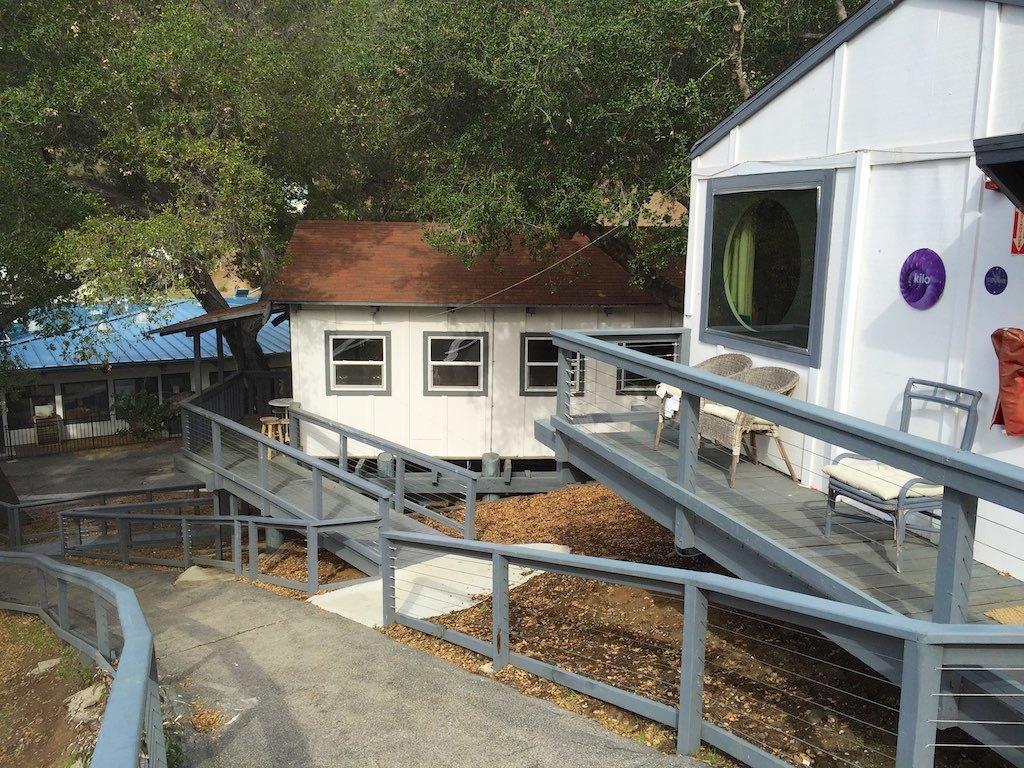How would you summarize this image in a sentence or two? In this picture we can see there are walkways, iron grilles, houses and trees. There are three chairs in the balcony. 